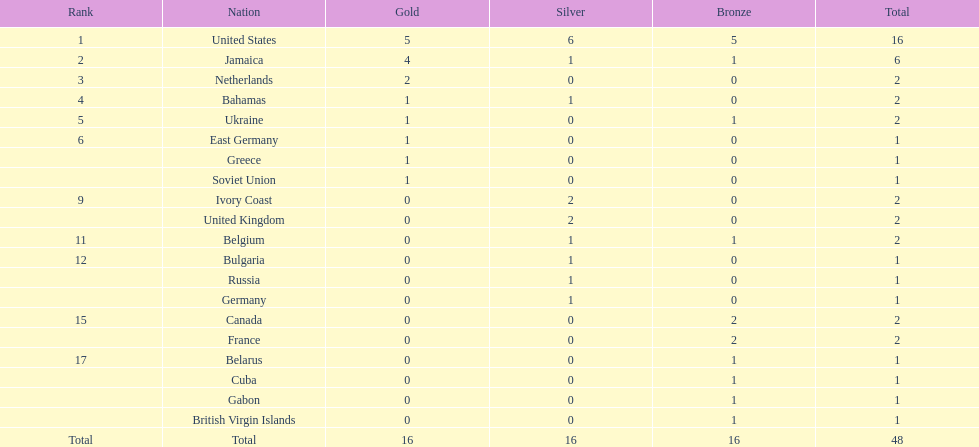After the united states, what country won the most gold medals. Jamaica. 